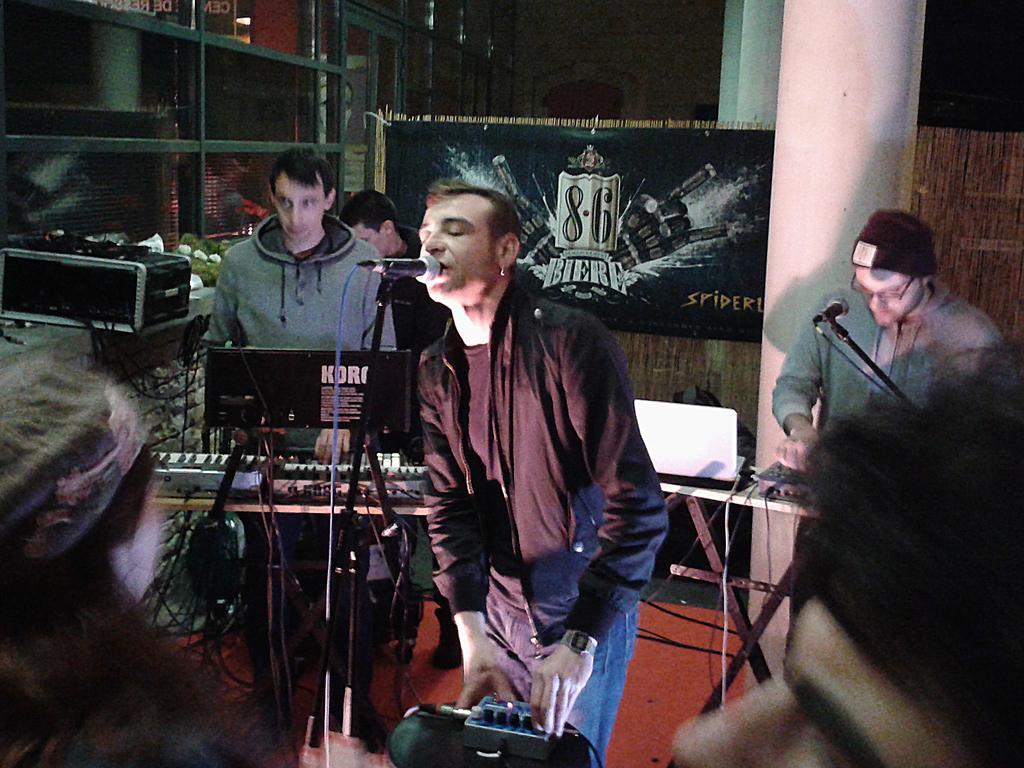Please provide a concise description of this image. In this image, we can see few people. Few are holding some objects. Here a person is singing in-front of a microphone. Background there is a banner, pillars, doors, rods. 